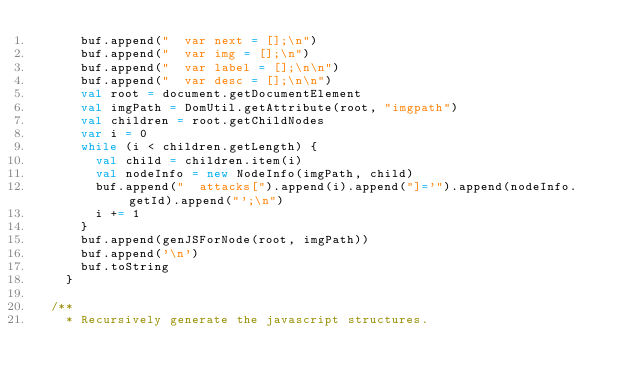<code> <loc_0><loc_0><loc_500><loc_500><_Scala_>      buf.append("  var next = [];\n")
      buf.append("  var img = [];\n")
      buf.append("  var label = [];\n\n")
      buf.append("  var desc = [];\n\n")
      val root = document.getDocumentElement
      val imgPath = DomUtil.getAttribute(root, "imgpath")
      val children = root.getChildNodes
      var i = 0
      while (i < children.getLength) {
        val child = children.item(i)
        val nodeInfo = new NodeInfo(imgPath, child)
        buf.append("  attacks[").append(i).append("]='").append(nodeInfo.getId).append("';\n")
        i += 1
      }
      buf.append(genJSForNode(root, imgPath))
      buf.append('\n')
      buf.toString
    }

  /**
    * Recursively generate the javascript structures.</code> 